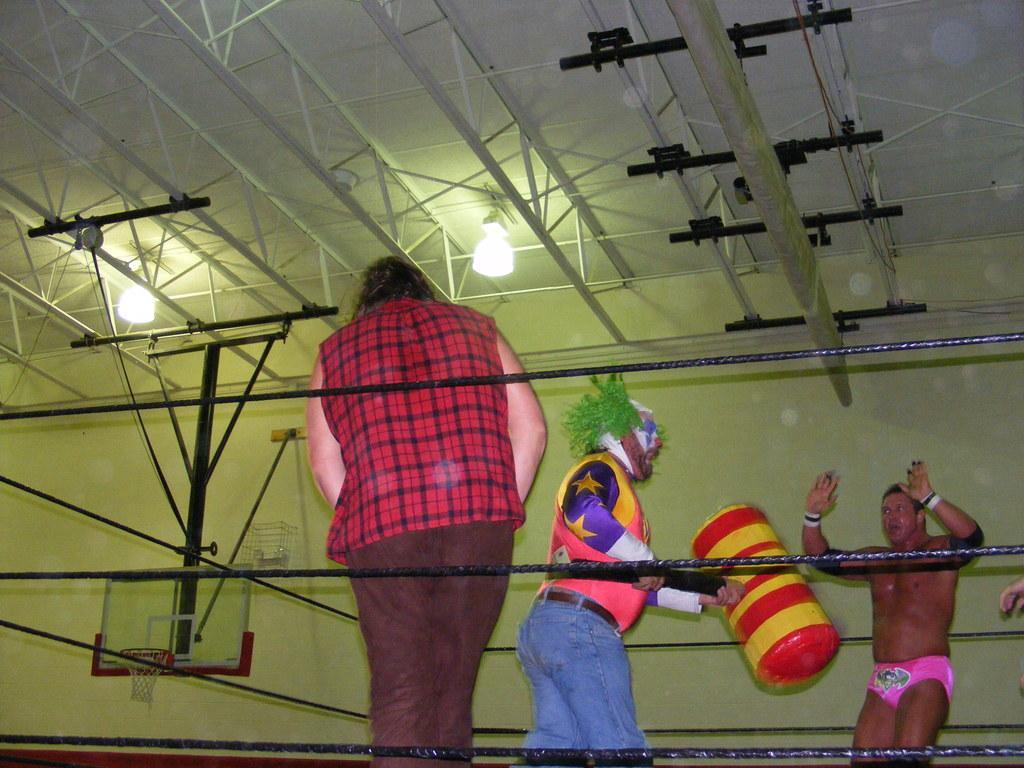Describe this image in one or two sentences. In the image there are ropes. Behind the ropes there are few people standing. At the top of the image there is a ceiling with rods and lights. In the background there are rods and basketball board with basket. 